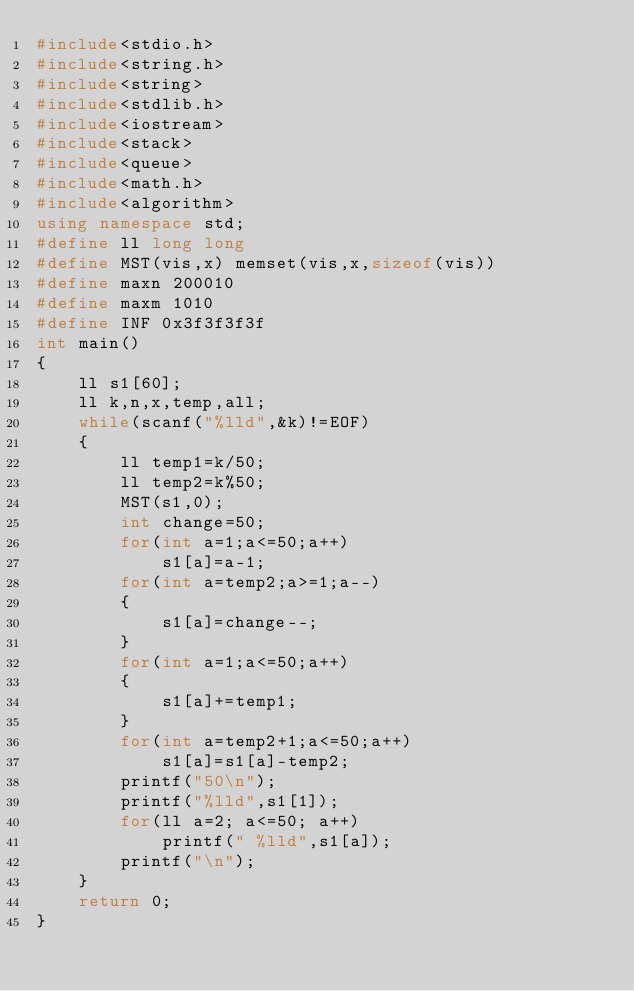Convert code to text. <code><loc_0><loc_0><loc_500><loc_500><_C++_>#include<stdio.h>
#include<string.h>
#include<string>
#include<stdlib.h>
#include<iostream>
#include<stack>
#include<queue>
#include<math.h>
#include<algorithm>
using namespace std;
#define ll long long
#define MST(vis,x) memset(vis,x,sizeof(vis))
#define maxn 200010
#define maxm 1010
#define INF 0x3f3f3f3f
int main()
{
    ll s1[60];
    ll k,n,x,temp,all;
    while(scanf("%lld",&k)!=EOF)
    {
        ll temp1=k/50;
        ll temp2=k%50;
        MST(s1,0);
        int change=50;
        for(int a=1;a<=50;a++)
            s1[a]=a-1;
        for(int a=temp2;a>=1;a--)
        {
            s1[a]=change--;
        }
        for(int a=1;a<=50;a++)
        {
            s1[a]+=temp1;
        }
        for(int a=temp2+1;a<=50;a++)
            s1[a]=s1[a]-temp2;
        printf("50\n");
        printf("%lld",s1[1]);
        for(ll a=2; a<=50; a++)
            printf(" %lld",s1[a]);
        printf("\n");
    }
    return 0;
}
</code> 